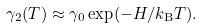Convert formula to latex. <formula><loc_0><loc_0><loc_500><loc_500>\gamma _ { 2 } ( T ) \approx \gamma _ { 0 } \exp ( - H / k _ { \mathrm B } T ) .</formula> 